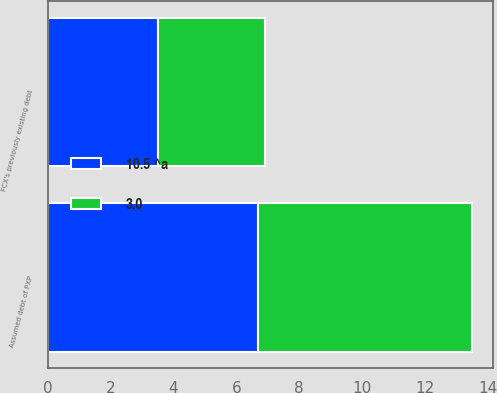Convert chart to OTSL. <chart><loc_0><loc_0><loc_500><loc_500><stacked_bar_chart><ecel><fcel>Assumed debt of PXP<fcel>FCX's previously existing debt<nl><fcel>10.5 ^a<fcel>6.7<fcel>3.5<nl><fcel>3.0<fcel>6.8<fcel>3.4<nl></chart> 